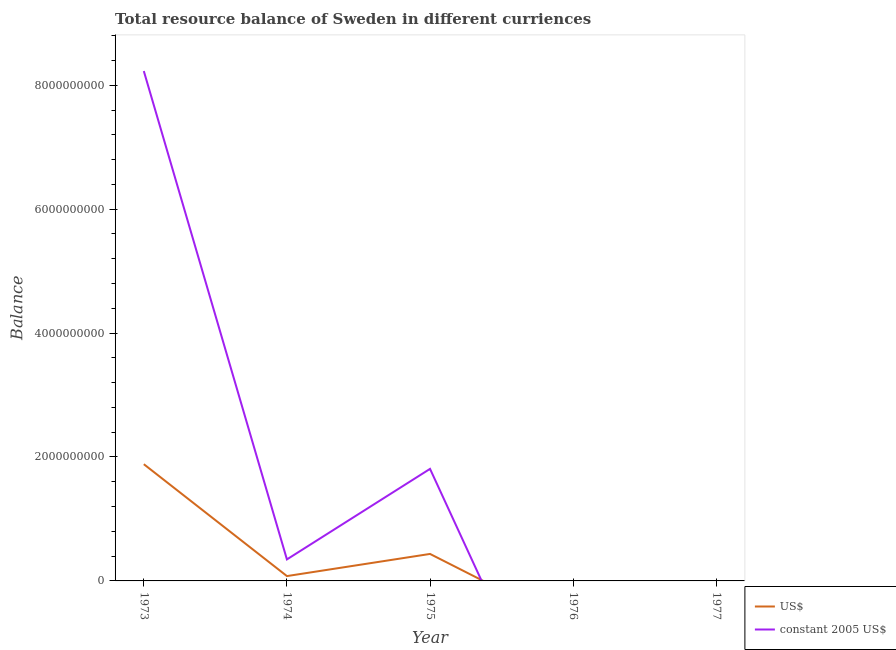How many different coloured lines are there?
Give a very brief answer. 2. What is the resource balance in us$ in 1974?
Provide a short and direct response. 7.82e+07. Across all years, what is the maximum resource balance in constant us$?
Offer a terse response. 8.23e+09. Across all years, what is the minimum resource balance in constant us$?
Provide a succinct answer. 0. What is the total resource balance in us$ in the graph?
Provide a short and direct response. 2.40e+09. What is the difference between the resource balance in constant us$ in 1974 and that in 1975?
Your response must be concise. -1.46e+09. What is the difference between the resource balance in constant us$ in 1974 and the resource balance in us$ in 1973?
Your answer should be very brief. -1.54e+09. What is the average resource balance in us$ per year?
Keep it short and to the point. 4.80e+08. In the year 1975, what is the difference between the resource balance in constant us$ and resource balance in us$?
Your answer should be very brief. 1.37e+09. What is the ratio of the resource balance in constant us$ in 1973 to that in 1974?
Provide a succinct answer. 23.7. Is the resource balance in us$ in 1973 less than that in 1975?
Ensure brevity in your answer.  No. What is the difference between the highest and the second highest resource balance in us$?
Provide a succinct answer. 1.45e+09. What is the difference between the highest and the lowest resource balance in us$?
Make the answer very short. 1.88e+09. Is the sum of the resource balance in constant us$ in 1973 and 1974 greater than the maximum resource balance in us$ across all years?
Provide a short and direct response. Yes. Does the resource balance in us$ monotonically increase over the years?
Ensure brevity in your answer.  No. Are the values on the major ticks of Y-axis written in scientific E-notation?
Offer a very short reply. No. Does the graph contain any zero values?
Your answer should be compact. Yes. Does the graph contain grids?
Provide a short and direct response. No. How many legend labels are there?
Offer a terse response. 2. How are the legend labels stacked?
Make the answer very short. Vertical. What is the title of the graph?
Your answer should be compact. Total resource balance of Sweden in different curriences. What is the label or title of the X-axis?
Give a very brief answer. Year. What is the label or title of the Y-axis?
Your answer should be very brief. Balance. What is the Balance of US$ in 1973?
Offer a very short reply. 1.88e+09. What is the Balance of constant 2005 US$ in 1973?
Provide a succinct answer. 8.23e+09. What is the Balance of US$ in 1974?
Offer a terse response. 7.82e+07. What is the Balance in constant 2005 US$ in 1974?
Your response must be concise. 3.47e+08. What is the Balance of US$ in 1975?
Provide a short and direct response. 4.35e+08. What is the Balance of constant 2005 US$ in 1975?
Your answer should be very brief. 1.81e+09. What is the Balance in US$ in 1976?
Your answer should be very brief. 0. What is the Balance of constant 2005 US$ in 1976?
Offer a very short reply. 0. What is the Balance in US$ in 1977?
Provide a succinct answer. 0. What is the Balance in constant 2005 US$ in 1977?
Your response must be concise. 0. Across all years, what is the maximum Balance of US$?
Make the answer very short. 1.88e+09. Across all years, what is the maximum Balance of constant 2005 US$?
Give a very brief answer. 8.23e+09. Across all years, what is the minimum Balance of US$?
Keep it short and to the point. 0. Across all years, what is the minimum Balance of constant 2005 US$?
Offer a terse response. 0. What is the total Balance of US$ in the graph?
Give a very brief answer. 2.40e+09. What is the total Balance of constant 2005 US$ in the graph?
Offer a very short reply. 1.04e+1. What is the difference between the Balance of US$ in 1973 and that in 1974?
Your answer should be very brief. 1.81e+09. What is the difference between the Balance in constant 2005 US$ in 1973 and that in 1974?
Offer a very short reply. 7.88e+09. What is the difference between the Balance of US$ in 1973 and that in 1975?
Offer a very short reply. 1.45e+09. What is the difference between the Balance of constant 2005 US$ in 1973 and that in 1975?
Offer a terse response. 6.42e+09. What is the difference between the Balance of US$ in 1974 and that in 1975?
Give a very brief answer. -3.57e+08. What is the difference between the Balance in constant 2005 US$ in 1974 and that in 1975?
Give a very brief answer. -1.46e+09. What is the difference between the Balance of US$ in 1973 and the Balance of constant 2005 US$ in 1974?
Your answer should be compact. 1.54e+09. What is the difference between the Balance of US$ in 1973 and the Balance of constant 2005 US$ in 1975?
Give a very brief answer. 7.60e+07. What is the difference between the Balance of US$ in 1974 and the Balance of constant 2005 US$ in 1975?
Keep it short and to the point. -1.73e+09. What is the average Balance in US$ per year?
Your answer should be very brief. 4.80e+08. What is the average Balance in constant 2005 US$ per year?
Your answer should be compact. 2.08e+09. In the year 1973, what is the difference between the Balance of US$ and Balance of constant 2005 US$?
Give a very brief answer. -6.34e+09. In the year 1974, what is the difference between the Balance in US$ and Balance in constant 2005 US$?
Your answer should be compact. -2.69e+08. In the year 1975, what is the difference between the Balance in US$ and Balance in constant 2005 US$?
Your answer should be compact. -1.37e+09. What is the ratio of the Balance in US$ in 1973 to that in 1974?
Offer a terse response. 24.09. What is the ratio of the Balance in constant 2005 US$ in 1973 to that in 1974?
Ensure brevity in your answer.  23.7. What is the ratio of the Balance in US$ in 1973 to that in 1975?
Your answer should be compact. 4.33. What is the ratio of the Balance of constant 2005 US$ in 1973 to that in 1975?
Provide a succinct answer. 4.55. What is the ratio of the Balance of US$ in 1974 to that in 1975?
Make the answer very short. 0.18. What is the ratio of the Balance of constant 2005 US$ in 1974 to that in 1975?
Keep it short and to the point. 0.19. What is the difference between the highest and the second highest Balance of US$?
Ensure brevity in your answer.  1.45e+09. What is the difference between the highest and the second highest Balance of constant 2005 US$?
Offer a terse response. 6.42e+09. What is the difference between the highest and the lowest Balance of US$?
Your answer should be compact. 1.88e+09. What is the difference between the highest and the lowest Balance in constant 2005 US$?
Provide a succinct answer. 8.23e+09. 